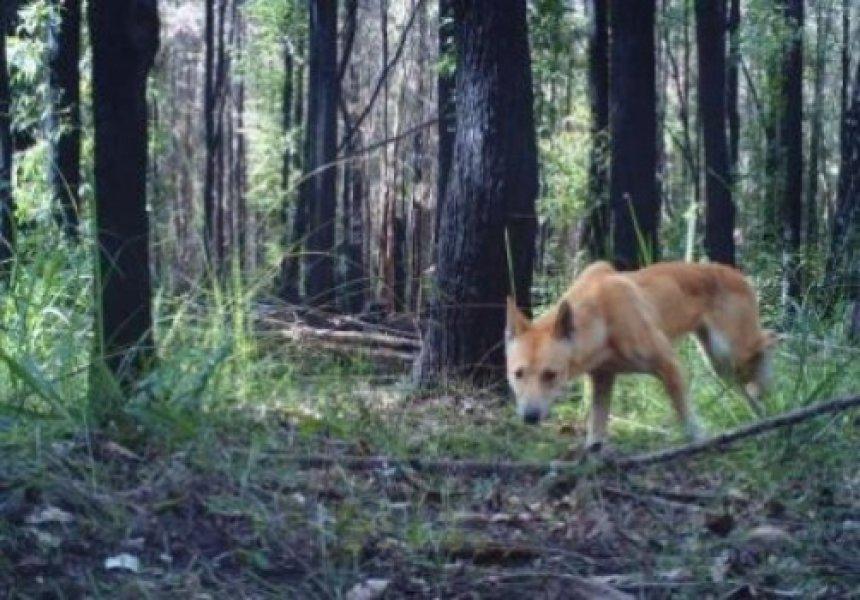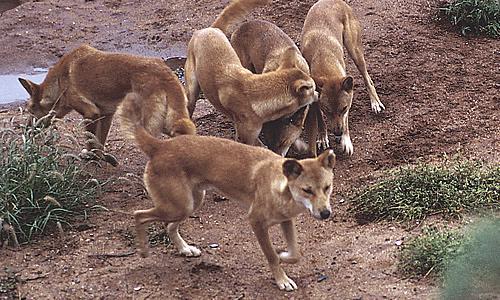The first image is the image on the left, the second image is the image on the right. Assess this claim about the two images: "An image shows an adult dog with at least one pup standing to reach it.". Correct or not? Answer yes or no. No. The first image is the image on the left, the second image is the image on the right. For the images shown, is this caption "There is only one animal in the picture on the left." true? Answer yes or no. Yes. 